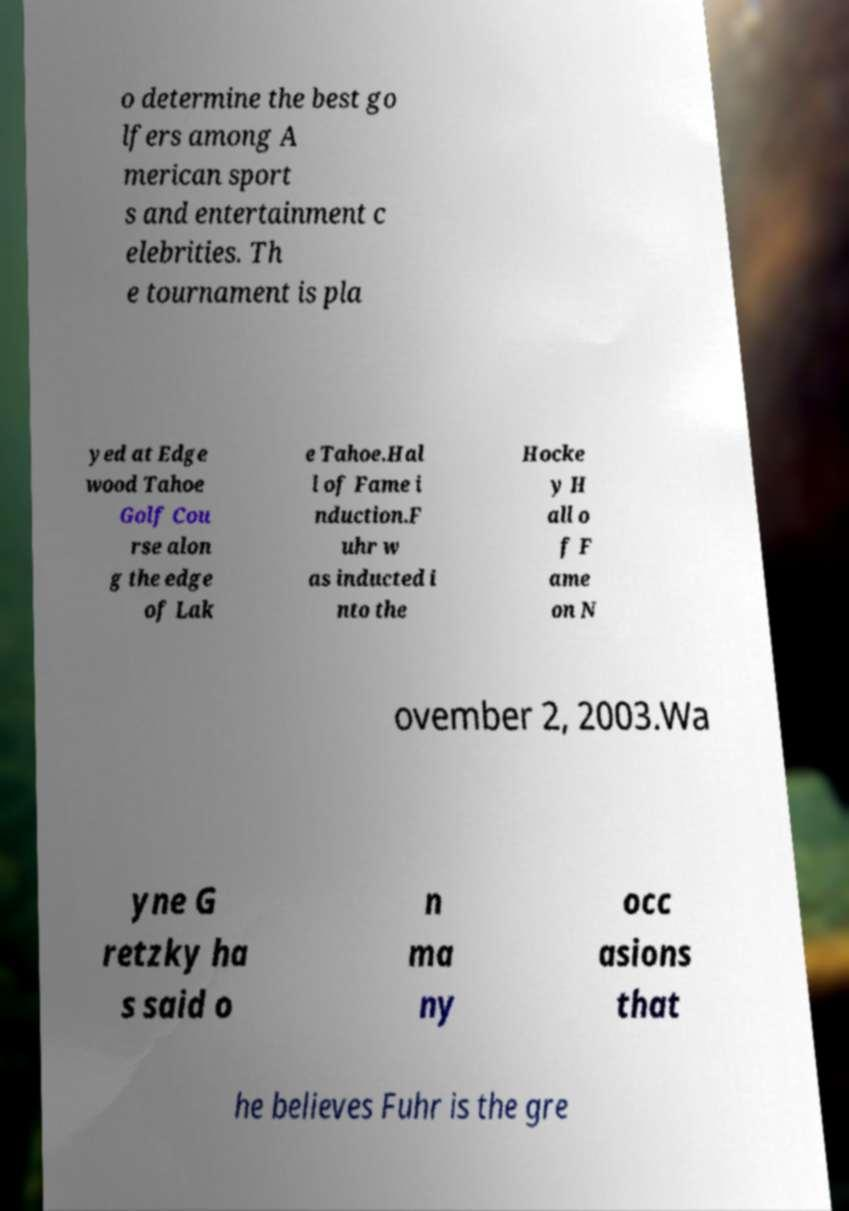For documentation purposes, I need the text within this image transcribed. Could you provide that? o determine the best go lfers among A merican sport s and entertainment c elebrities. Th e tournament is pla yed at Edge wood Tahoe Golf Cou rse alon g the edge of Lak e Tahoe.Hal l of Fame i nduction.F uhr w as inducted i nto the Hocke y H all o f F ame on N ovember 2, 2003.Wa yne G retzky ha s said o n ma ny occ asions that he believes Fuhr is the gre 